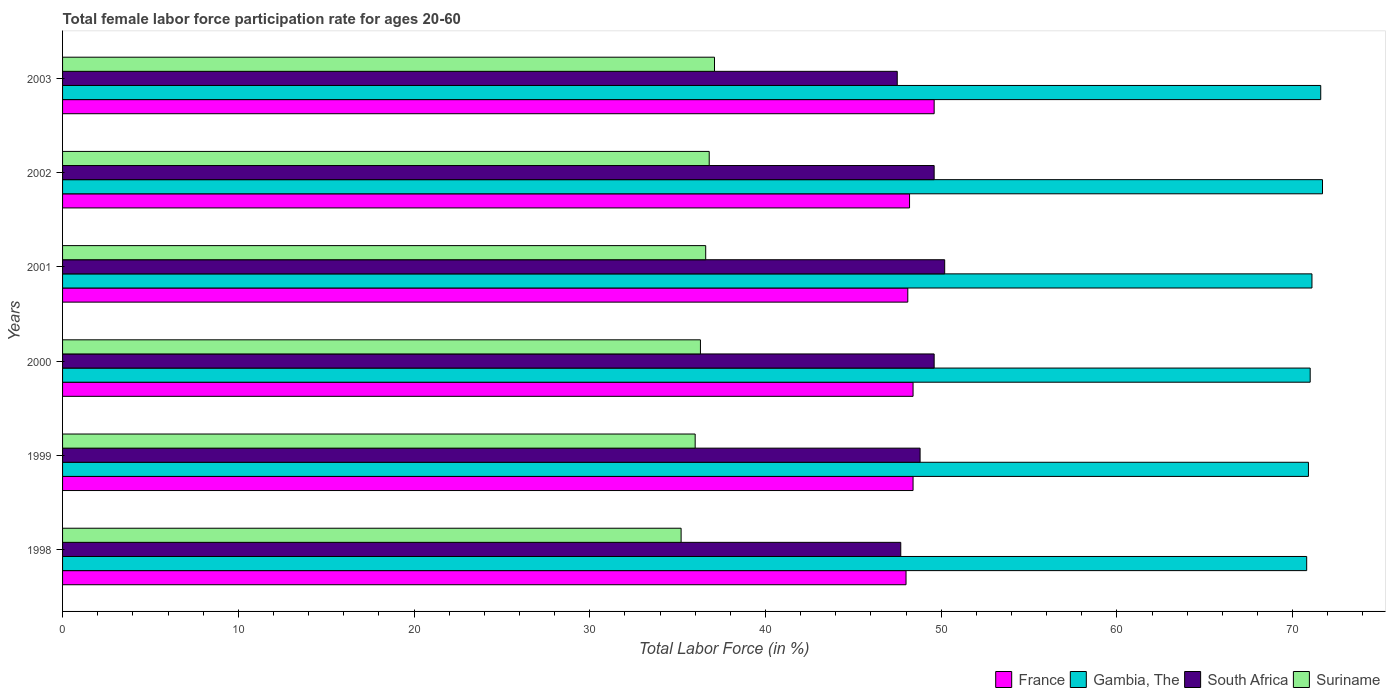How many different coloured bars are there?
Provide a succinct answer. 4. How many groups of bars are there?
Keep it short and to the point. 6. Are the number of bars per tick equal to the number of legend labels?
Your answer should be compact. Yes. How many bars are there on the 5th tick from the bottom?
Offer a very short reply. 4. In how many cases, is the number of bars for a given year not equal to the number of legend labels?
Provide a succinct answer. 0. What is the female labor force participation rate in France in 2002?
Provide a succinct answer. 48.2. Across all years, what is the maximum female labor force participation rate in South Africa?
Ensure brevity in your answer.  50.2. Across all years, what is the minimum female labor force participation rate in Gambia, The?
Make the answer very short. 70.8. In which year was the female labor force participation rate in Suriname maximum?
Make the answer very short. 2003. What is the total female labor force participation rate in Suriname in the graph?
Your response must be concise. 218. What is the difference between the female labor force participation rate in South Africa in 1999 and that in 2001?
Provide a short and direct response. -1.4. What is the difference between the female labor force participation rate in Suriname in 1998 and the female labor force participation rate in South Africa in 2003?
Provide a succinct answer. -12.3. What is the average female labor force participation rate in Suriname per year?
Ensure brevity in your answer.  36.33. In the year 2000, what is the difference between the female labor force participation rate in Gambia, The and female labor force participation rate in Suriname?
Offer a terse response. 34.7. In how many years, is the female labor force participation rate in Suriname greater than 66 %?
Make the answer very short. 0. What is the ratio of the female labor force participation rate in Gambia, The in 1998 to that in 1999?
Your answer should be very brief. 1. Is the difference between the female labor force participation rate in Gambia, The in 1998 and 1999 greater than the difference between the female labor force participation rate in Suriname in 1998 and 1999?
Provide a short and direct response. Yes. What is the difference between the highest and the second highest female labor force participation rate in Suriname?
Your response must be concise. 0.3. What is the difference between the highest and the lowest female labor force participation rate in France?
Ensure brevity in your answer.  1.6. In how many years, is the female labor force participation rate in Gambia, The greater than the average female labor force participation rate in Gambia, The taken over all years?
Your answer should be compact. 2. Is it the case that in every year, the sum of the female labor force participation rate in South Africa and female labor force participation rate in Suriname is greater than the sum of female labor force participation rate in Gambia, The and female labor force participation rate in France?
Keep it short and to the point. Yes. What does the 2nd bar from the bottom in 2003 represents?
Give a very brief answer. Gambia, The. How many bars are there?
Your response must be concise. 24. How many legend labels are there?
Offer a terse response. 4. What is the title of the graph?
Offer a very short reply. Total female labor force participation rate for ages 20-60. Does "World" appear as one of the legend labels in the graph?
Ensure brevity in your answer.  No. What is the Total Labor Force (in %) of Gambia, The in 1998?
Ensure brevity in your answer.  70.8. What is the Total Labor Force (in %) in South Africa in 1998?
Ensure brevity in your answer.  47.7. What is the Total Labor Force (in %) in Suriname in 1998?
Your response must be concise. 35.2. What is the Total Labor Force (in %) in France in 1999?
Your answer should be compact. 48.4. What is the Total Labor Force (in %) of Gambia, The in 1999?
Provide a succinct answer. 70.9. What is the Total Labor Force (in %) in South Africa in 1999?
Your response must be concise. 48.8. What is the Total Labor Force (in %) of France in 2000?
Offer a terse response. 48.4. What is the Total Labor Force (in %) of South Africa in 2000?
Ensure brevity in your answer.  49.6. What is the Total Labor Force (in %) of Suriname in 2000?
Offer a terse response. 36.3. What is the Total Labor Force (in %) of France in 2001?
Offer a terse response. 48.1. What is the Total Labor Force (in %) of Gambia, The in 2001?
Your response must be concise. 71.1. What is the Total Labor Force (in %) in South Africa in 2001?
Make the answer very short. 50.2. What is the Total Labor Force (in %) in Suriname in 2001?
Provide a short and direct response. 36.6. What is the Total Labor Force (in %) in France in 2002?
Provide a short and direct response. 48.2. What is the Total Labor Force (in %) in Gambia, The in 2002?
Your answer should be compact. 71.7. What is the Total Labor Force (in %) in South Africa in 2002?
Offer a very short reply. 49.6. What is the Total Labor Force (in %) in Suriname in 2002?
Offer a terse response. 36.8. What is the Total Labor Force (in %) in France in 2003?
Your answer should be very brief. 49.6. What is the Total Labor Force (in %) in Gambia, The in 2003?
Ensure brevity in your answer.  71.6. What is the Total Labor Force (in %) in South Africa in 2003?
Provide a short and direct response. 47.5. What is the Total Labor Force (in %) of Suriname in 2003?
Give a very brief answer. 37.1. Across all years, what is the maximum Total Labor Force (in %) in France?
Your answer should be compact. 49.6. Across all years, what is the maximum Total Labor Force (in %) of Gambia, The?
Keep it short and to the point. 71.7. Across all years, what is the maximum Total Labor Force (in %) of South Africa?
Provide a short and direct response. 50.2. Across all years, what is the maximum Total Labor Force (in %) of Suriname?
Make the answer very short. 37.1. Across all years, what is the minimum Total Labor Force (in %) in Gambia, The?
Offer a terse response. 70.8. Across all years, what is the minimum Total Labor Force (in %) in South Africa?
Offer a very short reply. 47.5. Across all years, what is the minimum Total Labor Force (in %) in Suriname?
Give a very brief answer. 35.2. What is the total Total Labor Force (in %) in France in the graph?
Your answer should be very brief. 290.7. What is the total Total Labor Force (in %) of Gambia, The in the graph?
Your answer should be compact. 427.1. What is the total Total Labor Force (in %) of South Africa in the graph?
Your response must be concise. 293.4. What is the total Total Labor Force (in %) of Suriname in the graph?
Give a very brief answer. 218. What is the difference between the Total Labor Force (in %) of France in 1998 and that in 2000?
Your answer should be very brief. -0.4. What is the difference between the Total Labor Force (in %) of Gambia, The in 1998 and that in 2000?
Give a very brief answer. -0.2. What is the difference between the Total Labor Force (in %) in South Africa in 1998 and that in 2000?
Offer a very short reply. -1.9. What is the difference between the Total Labor Force (in %) of Suriname in 1998 and that in 2000?
Provide a short and direct response. -1.1. What is the difference between the Total Labor Force (in %) of France in 1998 and that in 2001?
Offer a very short reply. -0.1. What is the difference between the Total Labor Force (in %) of Gambia, The in 1998 and that in 2001?
Provide a succinct answer. -0.3. What is the difference between the Total Labor Force (in %) in South Africa in 1998 and that in 2001?
Your response must be concise. -2.5. What is the difference between the Total Labor Force (in %) in Suriname in 1998 and that in 2001?
Ensure brevity in your answer.  -1.4. What is the difference between the Total Labor Force (in %) in France in 1998 and that in 2002?
Provide a succinct answer. -0.2. What is the difference between the Total Labor Force (in %) of Gambia, The in 1998 and that in 2003?
Your answer should be very brief. -0.8. What is the difference between the Total Labor Force (in %) of Suriname in 1998 and that in 2003?
Provide a short and direct response. -1.9. What is the difference between the Total Labor Force (in %) in France in 1999 and that in 2001?
Make the answer very short. 0.3. What is the difference between the Total Labor Force (in %) in Gambia, The in 1999 and that in 2001?
Provide a succinct answer. -0.2. What is the difference between the Total Labor Force (in %) in South Africa in 1999 and that in 2001?
Ensure brevity in your answer.  -1.4. What is the difference between the Total Labor Force (in %) of Suriname in 1999 and that in 2001?
Your answer should be compact. -0.6. What is the difference between the Total Labor Force (in %) in Gambia, The in 1999 and that in 2002?
Your answer should be very brief. -0.8. What is the difference between the Total Labor Force (in %) of France in 1999 and that in 2003?
Offer a terse response. -1.2. What is the difference between the Total Labor Force (in %) of Gambia, The in 1999 and that in 2003?
Keep it short and to the point. -0.7. What is the difference between the Total Labor Force (in %) in South Africa in 1999 and that in 2003?
Provide a short and direct response. 1.3. What is the difference between the Total Labor Force (in %) in South Africa in 2000 and that in 2001?
Keep it short and to the point. -0.6. What is the difference between the Total Labor Force (in %) of Suriname in 2000 and that in 2001?
Offer a terse response. -0.3. What is the difference between the Total Labor Force (in %) of South Africa in 2000 and that in 2002?
Make the answer very short. 0. What is the difference between the Total Labor Force (in %) of Suriname in 2000 and that in 2002?
Provide a short and direct response. -0.5. What is the difference between the Total Labor Force (in %) in France in 2000 and that in 2003?
Your answer should be compact. -1.2. What is the difference between the Total Labor Force (in %) of Gambia, The in 2000 and that in 2003?
Offer a terse response. -0.6. What is the difference between the Total Labor Force (in %) in South Africa in 2000 and that in 2003?
Your answer should be compact. 2.1. What is the difference between the Total Labor Force (in %) of France in 2001 and that in 2002?
Provide a succinct answer. -0.1. What is the difference between the Total Labor Force (in %) in Gambia, The in 2001 and that in 2002?
Provide a short and direct response. -0.6. What is the difference between the Total Labor Force (in %) in South Africa in 2001 and that in 2002?
Provide a succinct answer. 0.6. What is the difference between the Total Labor Force (in %) in France in 2001 and that in 2003?
Make the answer very short. -1.5. What is the difference between the Total Labor Force (in %) in Gambia, The in 2001 and that in 2003?
Make the answer very short. -0.5. What is the difference between the Total Labor Force (in %) of South Africa in 2001 and that in 2003?
Give a very brief answer. 2.7. What is the difference between the Total Labor Force (in %) in Suriname in 2001 and that in 2003?
Your answer should be very brief. -0.5. What is the difference between the Total Labor Force (in %) in France in 2002 and that in 2003?
Give a very brief answer. -1.4. What is the difference between the Total Labor Force (in %) in South Africa in 2002 and that in 2003?
Give a very brief answer. 2.1. What is the difference between the Total Labor Force (in %) of Suriname in 2002 and that in 2003?
Ensure brevity in your answer.  -0.3. What is the difference between the Total Labor Force (in %) of France in 1998 and the Total Labor Force (in %) of Gambia, The in 1999?
Ensure brevity in your answer.  -22.9. What is the difference between the Total Labor Force (in %) in Gambia, The in 1998 and the Total Labor Force (in %) in South Africa in 1999?
Keep it short and to the point. 22. What is the difference between the Total Labor Force (in %) in Gambia, The in 1998 and the Total Labor Force (in %) in Suriname in 1999?
Provide a succinct answer. 34.8. What is the difference between the Total Labor Force (in %) of France in 1998 and the Total Labor Force (in %) of Gambia, The in 2000?
Your response must be concise. -23. What is the difference between the Total Labor Force (in %) in France in 1998 and the Total Labor Force (in %) in South Africa in 2000?
Give a very brief answer. -1.6. What is the difference between the Total Labor Force (in %) in France in 1998 and the Total Labor Force (in %) in Suriname in 2000?
Offer a very short reply. 11.7. What is the difference between the Total Labor Force (in %) in Gambia, The in 1998 and the Total Labor Force (in %) in South Africa in 2000?
Offer a very short reply. 21.2. What is the difference between the Total Labor Force (in %) in Gambia, The in 1998 and the Total Labor Force (in %) in Suriname in 2000?
Your answer should be very brief. 34.5. What is the difference between the Total Labor Force (in %) in South Africa in 1998 and the Total Labor Force (in %) in Suriname in 2000?
Provide a short and direct response. 11.4. What is the difference between the Total Labor Force (in %) in France in 1998 and the Total Labor Force (in %) in Gambia, The in 2001?
Your answer should be compact. -23.1. What is the difference between the Total Labor Force (in %) of France in 1998 and the Total Labor Force (in %) of South Africa in 2001?
Provide a short and direct response. -2.2. What is the difference between the Total Labor Force (in %) in France in 1998 and the Total Labor Force (in %) in Suriname in 2001?
Provide a short and direct response. 11.4. What is the difference between the Total Labor Force (in %) in Gambia, The in 1998 and the Total Labor Force (in %) in South Africa in 2001?
Your answer should be compact. 20.6. What is the difference between the Total Labor Force (in %) in Gambia, The in 1998 and the Total Labor Force (in %) in Suriname in 2001?
Ensure brevity in your answer.  34.2. What is the difference between the Total Labor Force (in %) of France in 1998 and the Total Labor Force (in %) of Gambia, The in 2002?
Provide a short and direct response. -23.7. What is the difference between the Total Labor Force (in %) of France in 1998 and the Total Labor Force (in %) of South Africa in 2002?
Your response must be concise. -1.6. What is the difference between the Total Labor Force (in %) of France in 1998 and the Total Labor Force (in %) of Suriname in 2002?
Give a very brief answer. 11.2. What is the difference between the Total Labor Force (in %) of Gambia, The in 1998 and the Total Labor Force (in %) of South Africa in 2002?
Your answer should be very brief. 21.2. What is the difference between the Total Labor Force (in %) of South Africa in 1998 and the Total Labor Force (in %) of Suriname in 2002?
Provide a short and direct response. 10.9. What is the difference between the Total Labor Force (in %) of France in 1998 and the Total Labor Force (in %) of Gambia, The in 2003?
Ensure brevity in your answer.  -23.6. What is the difference between the Total Labor Force (in %) in France in 1998 and the Total Labor Force (in %) in South Africa in 2003?
Ensure brevity in your answer.  0.5. What is the difference between the Total Labor Force (in %) in France in 1998 and the Total Labor Force (in %) in Suriname in 2003?
Provide a succinct answer. 10.9. What is the difference between the Total Labor Force (in %) in Gambia, The in 1998 and the Total Labor Force (in %) in South Africa in 2003?
Ensure brevity in your answer.  23.3. What is the difference between the Total Labor Force (in %) of Gambia, The in 1998 and the Total Labor Force (in %) of Suriname in 2003?
Provide a succinct answer. 33.7. What is the difference between the Total Labor Force (in %) in France in 1999 and the Total Labor Force (in %) in Gambia, The in 2000?
Keep it short and to the point. -22.6. What is the difference between the Total Labor Force (in %) of Gambia, The in 1999 and the Total Labor Force (in %) of South Africa in 2000?
Keep it short and to the point. 21.3. What is the difference between the Total Labor Force (in %) of Gambia, The in 1999 and the Total Labor Force (in %) of Suriname in 2000?
Provide a succinct answer. 34.6. What is the difference between the Total Labor Force (in %) in South Africa in 1999 and the Total Labor Force (in %) in Suriname in 2000?
Make the answer very short. 12.5. What is the difference between the Total Labor Force (in %) of France in 1999 and the Total Labor Force (in %) of Gambia, The in 2001?
Keep it short and to the point. -22.7. What is the difference between the Total Labor Force (in %) of France in 1999 and the Total Labor Force (in %) of Suriname in 2001?
Your answer should be compact. 11.8. What is the difference between the Total Labor Force (in %) in Gambia, The in 1999 and the Total Labor Force (in %) in South Africa in 2001?
Your answer should be very brief. 20.7. What is the difference between the Total Labor Force (in %) of Gambia, The in 1999 and the Total Labor Force (in %) of Suriname in 2001?
Your response must be concise. 34.3. What is the difference between the Total Labor Force (in %) of South Africa in 1999 and the Total Labor Force (in %) of Suriname in 2001?
Offer a terse response. 12.2. What is the difference between the Total Labor Force (in %) in France in 1999 and the Total Labor Force (in %) in Gambia, The in 2002?
Offer a terse response. -23.3. What is the difference between the Total Labor Force (in %) of France in 1999 and the Total Labor Force (in %) of Suriname in 2002?
Offer a terse response. 11.6. What is the difference between the Total Labor Force (in %) in Gambia, The in 1999 and the Total Labor Force (in %) in South Africa in 2002?
Give a very brief answer. 21.3. What is the difference between the Total Labor Force (in %) of Gambia, The in 1999 and the Total Labor Force (in %) of Suriname in 2002?
Ensure brevity in your answer.  34.1. What is the difference between the Total Labor Force (in %) in France in 1999 and the Total Labor Force (in %) in Gambia, The in 2003?
Give a very brief answer. -23.2. What is the difference between the Total Labor Force (in %) in France in 1999 and the Total Labor Force (in %) in Suriname in 2003?
Make the answer very short. 11.3. What is the difference between the Total Labor Force (in %) of Gambia, The in 1999 and the Total Labor Force (in %) of South Africa in 2003?
Keep it short and to the point. 23.4. What is the difference between the Total Labor Force (in %) of Gambia, The in 1999 and the Total Labor Force (in %) of Suriname in 2003?
Your answer should be compact. 33.8. What is the difference between the Total Labor Force (in %) of France in 2000 and the Total Labor Force (in %) of Gambia, The in 2001?
Your answer should be compact. -22.7. What is the difference between the Total Labor Force (in %) in France in 2000 and the Total Labor Force (in %) in Suriname in 2001?
Provide a succinct answer. 11.8. What is the difference between the Total Labor Force (in %) of Gambia, The in 2000 and the Total Labor Force (in %) of South Africa in 2001?
Keep it short and to the point. 20.8. What is the difference between the Total Labor Force (in %) in Gambia, The in 2000 and the Total Labor Force (in %) in Suriname in 2001?
Give a very brief answer. 34.4. What is the difference between the Total Labor Force (in %) in South Africa in 2000 and the Total Labor Force (in %) in Suriname in 2001?
Ensure brevity in your answer.  13. What is the difference between the Total Labor Force (in %) in France in 2000 and the Total Labor Force (in %) in Gambia, The in 2002?
Ensure brevity in your answer.  -23.3. What is the difference between the Total Labor Force (in %) of France in 2000 and the Total Labor Force (in %) of Suriname in 2002?
Give a very brief answer. 11.6. What is the difference between the Total Labor Force (in %) in Gambia, The in 2000 and the Total Labor Force (in %) in South Africa in 2002?
Provide a short and direct response. 21.4. What is the difference between the Total Labor Force (in %) in Gambia, The in 2000 and the Total Labor Force (in %) in Suriname in 2002?
Give a very brief answer. 34.2. What is the difference between the Total Labor Force (in %) in France in 2000 and the Total Labor Force (in %) in Gambia, The in 2003?
Provide a succinct answer. -23.2. What is the difference between the Total Labor Force (in %) of France in 2000 and the Total Labor Force (in %) of South Africa in 2003?
Provide a short and direct response. 0.9. What is the difference between the Total Labor Force (in %) of Gambia, The in 2000 and the Total Labor Force (in %) of South Africa in 2003?
Provide a short and direct response. 23.5. What is the difference between the Total Labor Force (in %) in Gambia, The in 2000 and the Total Labor Force (in %) in Suriname in 2003?
Ensure brevity in your answer.  33.9. What is the difference between the Total Labor Force (in %) in South Africa in 2000 and the Total Labor Force (in %) in Suriname in 2003?
Make the answer very short. 12.5. What is the difference between the Total Labor Force (in %) of France in 2001 and the Total Labor Force (in %) of Gambia, The in 2002?
Give a very brief answer. -23.6. What is the difference between the Total Labor Force (in %) of France in 2001 and the Total Labor Force (in %) of South Africa in 2002?
Keep it short and to the point. -1.5. What is the difference between the Total Labor Force (in %) in France in 2001 and the Total Labor Force (in %) in Suriname in 2002?
Your answer should be very brief. 11.3. What is the difference between the Total Labor Force (in %) in Gambia, The in 2001 and the Total Labor Force (in %) in Suriname in 2002?
Offer a very short reply. 34.3. What is the difference between the Total Labor Force (in %) in South Africa in 2001 and the Total Labor Force (in %) in Suriname in 2002?
Provide a short and direct response. 13.4. What is the difference between the Total Labor Force (in %) in France in 2001 and the Total Labor Force (in %) in Gambia, The in 2003?
Provide a short and direct response. -23.5. What is the difference between the Total Labor Force (in %) in France in 2001 and the Total Labor Force (in %) in Suriname in 2003?
Offer a very short reply. 11. What is the difference between the Total Labor Force (in %) in Gambia, The in 2001 and the Total Labor Force (in %) in South Africa in 2003?
Your answer should be compact. 23.6. What is the difference between the Total Labor Force (in %) in Gambia, The in 2001 and the Total Labor Force (in %) in Suriname in 2003?
Ensure brevity in your answer.  34. What is the difference between the Total Labor Force (in %) of France in 2002 and the Total Labor Force (in %) of Gambia, The in 2003?
Your response must be concise. -23.4. What is the difference between the Total Labor Force (in %) in Gambia, The in 2002 and the Total Labor Force (in %) in South Africa in 2003?
Ensure brevity in your answer.  24.2. What is the difference between the Total Labor Force (in %) in Gambia, The in 2002 and the Total Labor Force (in %) in Suriname in 2003?
Ensure brevity in your answer.  34.6. What is the average Total Labor Force (in %) in France per year?
Your answer should be very brief. 48.45. What is the average Total Labor Force (in %) in Gambia, The per year?
Your answer should be very brief. 71.18. What is the average Total Labor Force (in %) in South Africa per year?
Provide a short and direct response. 48.9. What is the average Total Labor Force (in %) of Suriname per year?
Your response must be concise. 36.33. In the year 1998, what is the difference between the Total Labor Force (in %) in France and Total Labor Force (in %) in Gambia, The?
Your answer should be compact. -22.8. In the year 1998, what is the difference between the Total Labor Force (in %) in France and Total Labor Force (in %) in Suriname?
Your answer should be very brief. 12.8. In the year 1998, what is the difference between the Total Labor Force (in %) in Gambia, The and Total Labor Force (in %) in South Africa?
Offer a terse response. 23.1. In the year 1998, what is the difference between the Total Labor Force (in %) of Gambia, The and Total Labor Force (in %) of Suriname?
Ensure brevity in your answer.  35.6. In the year 1999, what is the difference between the Total Labor Force (in %) in France and Total Labor Force (in %) in Gambia, The?
Ensure brevity in your answer.  -22.5. In the year 1999, what is the difference between the Total Labor Force (in %) of France and Total Labor Force (in %) of South Africa?
Give a very brief answer. -0.4. In the year 1999, what is the difference between the Total Labor Force (in %) in Gambia, The and Total Labor Force (in %) in South Africa?
Offer a terse response. 22.1. In the year 1999, what is the difference between the Total Labor Force (in %) of Gambia, The and Total Labor Force (in %) of Suriname?
Your answer should be compact. 34.9. In the year 2000, what is the difference between the Total Labor Force (in %) of France and Total Labor Force (in %) of Gambia, The?
Ensure brevity in your answer.  -22.6. In the year 2000, what is the difference between the Total Labor Force (in %) in France and Total Labor Force (in %) in South Africa?
Ensure brevity in your answer.  -1.2. In the year 2000, what is the difference between the Total Labor Force (in %) in Gambia, The and Total Labor Force (in %) in South Africa?
Provide a succinct answer. 21.4. In the year 2000, what is the difference between the Total Labor Force (in %) of Gambia, The and Total Labor Force (in %) of Suriname?
Keep it short and to the point. 34.7. In the year 2001, what is the difference between the Total Labor Force (in %) of Gambia, The and Total Labor Force (in %) of South Africa?
Provide a succinct answer. 20.9. In the year 2001, what is the difference between the Total Labor Force (in %) in Gambia, The and Total Labor Force (in %) in Suriname?
Provide a succinct answer. 34.5. In the year 2002, what is the difference between the Total Labor Force (in %) of France and Total Labor Force (in %) of Gambia, The?
Offer a terse response. -23.5. In the year 2002, what is the difference between the Total Labor Force (in %) of France and Total Labor Force (in %) of Suriname?
Keep it short and to the point. 11.4. In the year 2002, what is the difference between the Total Labor Force (in %) in Gambia, The and Total Labor Force (in %) in South Africa?
Your answer should be compact. 22.1. In the year 2002, what is the difference between the Total Labor Force (in %) in Gambia, The and Total Labor Force (in %) in Suriname?
Offer a very short reply. 34.9. In the year 2002, what is the difference between the Total Labor Force (in %) in South Africa and Total Labor Force (in %) in Suriname?
Your response must be concise. 12.8. In the year 2003, what is the difference between the Total Labor Force (in %) in France and Total Labor Force (in %) in Gambia, The?
Offer a terse response. -22. In the year 2003, what is the difference between the Total Labor Force (in %) of France and Total Labor Force (in %) of Suriname?
Your answer should be compact. 12.5. In the year 2003, what is the difference between the Total Labor Force (in %) of Gambia, The and Total Labor Force (in %) of South Africa?
Keep it short and to the point. 24.1. In the year 2003, what is the difference between the Total Labor Force (in %) in Gambia, The and Total Labor Force (in %) in Suriname?
Your answer should be very brief. 34.5. In the year 2003, what is the difference between the Total Labor Force (in %) of South Africa and Total Labor Force (in %) of Suriname?
Make the answer very short. 10.4. What is the ratio of the Total Labor Force (in %) of France in 1998 to that in 1999?
Offer a terse response. 0.99. What is the ratio of the Total Labor Force (in %) in Gambia, The in 1998 to that in 1999?
Your response must be concise. 1. What is the ratio of the Total Labor Force (in %) in South Africa in 1998 to that in 1999?
Give a very brief answer. 0.98. What is the ratio of the Total Labor Force (in %) in Suriname in 1998 to that in 1999?
Provide a succinct answer. 0.98. What is the ratio of the Total Labor Force (in %) in Gambia, The in 1998 to that in 2000?
Your answer should be very brief. 1. What is the ratio of the Total Labor Force (in %) of South Africa in 1998 to that in 2000?
Provide a short and direct response. 0.96. What is the ratio of the Total Labor Force (in %) of Suriname in 1998 to that in 2000?
Offer a terse response. 0.97. What is the ratio of the Total Labor Force (in %) of Gambia, The in 1998 to that in 2001?
Give a very brief answer. 1. What is the ratio of the Total Labor Force (in %) in South Africa in 1998 to that in 2001?
Give a very brief answer. 0.95. What is the ratio of the Total Labor Force (in %) in Suriname in 1998 to that in 2001?
Provide a succinct answer. 0.96. What is the ratio of the Total Labor Force (in %) of Gambia, The in 1998 to that in 2002?
Your answer should be compact. 0.99. What is the ratio of the Total Labor Force (in %) of South Africa in 1998 to that in 2002?
Your answer should be very brief. 0.96. What is the ratio of the Total Labor Force (in %) in Suriname in 1998 to that in 2002?
Keep it short and to the point. 0.96. What is the ratio of the Total Labor Force (in %) in Gambia, The in 1998 to that in 2003?
Your answer should be compact. 0.99. What is the ratio of the Total Labor Force (in %) in Suriname in 1998 to that in 2003?
Ensure brevity in your answer.  0.95. What is the ratio of the Total Labor Force (in %) of France in 1999 to that in 2000?
Give a very brief answer. 1. What is the ratio of the Total Labor Force (in %) in South Africa in 1999 to that in 2000?
Your answer should be very brief. 0.98. What is the ratio of the Total Labor Force (in %) in France in 1999 to that in 2001?
Keep it short and to the point. 1.01. What is the ratio of the Total Labor Force (in %) of Gambia, The in 1999 to that in 2001?
Provide a succinct answer. 1. What is the ratio of the Total Labor Force (in %) in South Africa in 1999 to that in 2001?
Offer a very short reply. 0.97. What is the ratio of the Total Labor Force (in %) of Suriname in 1999 to that in 2001?
Offer a very short reply. 0.98. What is the ratio of the Total Labor Force (in %) of Gambia, The in 1999 to that in 2002?
Make the answer very short. 0.99. What is the ratio of the Total Labor Force (in %) in South Africa in 1999 to that in 2002?
Provide a short and direct response. 0.98. What is the ratio of the Total Labor Force (in %) in Suriname in 1999 to that in 2002?
Make the answer very short. 0.98. What is the ratio of the Total Labor Force (in %) of France in 1999 to that in 2003?
Your response must be concise. 0.98. What is the ratio of the Total Labor Force (in %) of Gambia, The in 1999 to that in 2003?
Make the answer very short. 0.99. What is the ratio of the Total Labor Force (in %) in South Africa in 1999 to that in 2003?
Keep it short and to the point. 1.03. What is the ratio of the Total Labor Force (in %) of Suriname in 1999 to that in 2003?
Keep it short and to the point. 0.97. What is the ratio of the Total Labor Force (in %) in France in 2000 to that in 2001?
Make the answer very short. 1.01. What is the ratio of the Total Labor Force (in %) in Suriname in 2000 to that in 2001?
Offer a terse response. 0.99. What is the ratio of the Total Labor Force (in %) in Gambia, The in 2000 to that in 2002?
Offer a terse response. 0.99. What is the ratio of the Total Labor Force (in %) of Suriname in 2000 to that in 2002?
Offer a terse response. 0.99. What is the ratio of the Total Labor Force (in %) in France in 2000 to that in 2003?
Give a very brief answer. 0.98. What is the ratio of the Total Labor Force (in %) of South Africa in 2000 to that in 2003?
Offer a terse response. 1.04. What is the ratio of the Total Labor Force (in %) in Suriname in 2000 to that in 2003?
Ensure brevity in your answer.  0.98. What is the ratio of the Total Labor Force (in %) of France in 2001 to that in 2002?
Your answer should be very brief. 1. What is the ratio of the Total Labor Force (in %) in South Africa in 2001 to that in 2002?
Your answer should be very brief. 1.01. What is the ratio of the Total Labor Force (in %) in Suriname in 2001 to that in 2002?
Give a very brief answer. 0.99. What is the ratio of the Total Labor Force (in %) of France in 2001 to that in 2003?
Offer a terse response. 0.97. What is the ratio of the Total Labor Force (in %) in Gambia, The in 2001 to that in 2003?
Provide a succinct answer. 0.99. What is the ratio of the Total Labor Force (in %) of South Africa in 2001 to that in 2003?
Your response must be concise. 1.06. What is the ratio of the Total Labor Force (in %) in Suriname in 2001 to that in 2003?
Provide a succinct answer. 0.99. What is the ratio of the Total Labor Force (in %) in France in 2002 to that in 2003?
Your answer should be compact. 0.97. What is the ratio of the Total Labor Force (in %) in South Africa in 2002 to that in 2003?
Provide a succinct answer. 1.04. What is the difference between the highest and the second highest Total Labor Force (in %) in Suriname?
Offer a very short reply. 0.3. What is the difference between the highest and the lowest Total Labor Force (in %) of France?
Your response must be concise. 1.6. What is the difference between the highest and the lowest Total Labor Force (in %) of Gambia, The?
Your response must be concise. 0.9. What is the difference between the highest and the lowest Total Labor Force (in %) of South Africa?
Make the answer very short. 2.7. What is the difference between the highest and the lowest Total Labor Force (in %) in Suriname?
Provide a succinct answer. 1.9. 